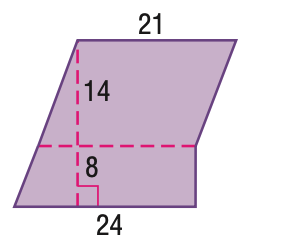Question: Find the area of the figure. Round to the nearest tenth.
Choices:
A. 462
B. 474
C. 486
D. 495
Answer with the letter. Answer: B 